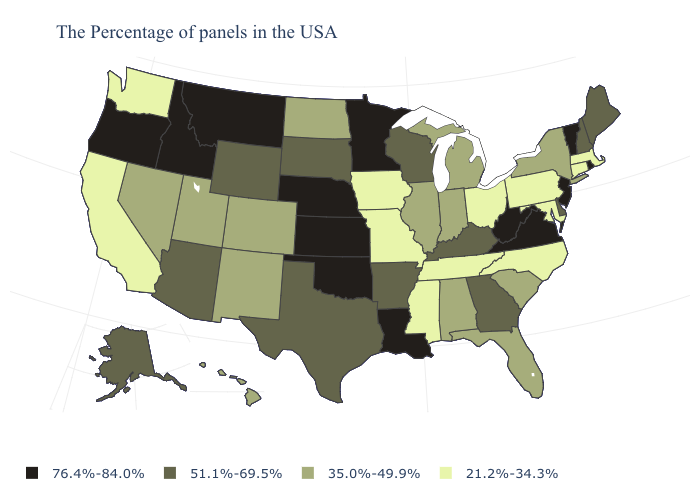What is the lowest value in states that border New Hampshire?
Short answer required. 21.2%-34.3%. How many symbols are there in the legend?
Give a very brief answer. 4. Does Delaware have a higher value than Wyoming?
Quick response, please. No. What is the value of Texas?
Concise answer only. 51.1%-69.5%. What is the value of Kansas?
Be succinct. 76.4%-84.0%. What is the highest value in states that border California?
Be succinct. 76.4%-84.0%. What is the highest value in states that border Pennsylvania?
Keep it brief. 76.4%-84.0%. Name the states that have a value in the range 76.4%-84.0%?
Write a very short answer. Rhode Island, Vermont, New Jersey, Virginia, West Virginia, Louisiana, Minnesota, Kansas, Nebraska, Oklahoma, Montana, Idaho, Oregon. Does Kansas have a higher value than Minnesota?
Short answer required. No. Among the states that border Delaware , does New Jersey have the highest value?
Concise answer only. Yes. Does the map have missing data?
Answer briefly. No. Name the states that have a value in the range 51.1%-69.5%?
Answer briefly. Maine, New Hampshire, Delaware, Georgia, Kentucky, Wisconsin, Arkansas, Texas, South Dakota, Wyoming, Arizona, Alaska. Among the states that border Delaware , which have the highest value?
Short answer required. New Jersey. What is the value of Rhode Island?
Answer briefly. 76.4%-84.0%. Among the states that border Wisconsin , which have the highest value?
Be succinct. Minnesota. 